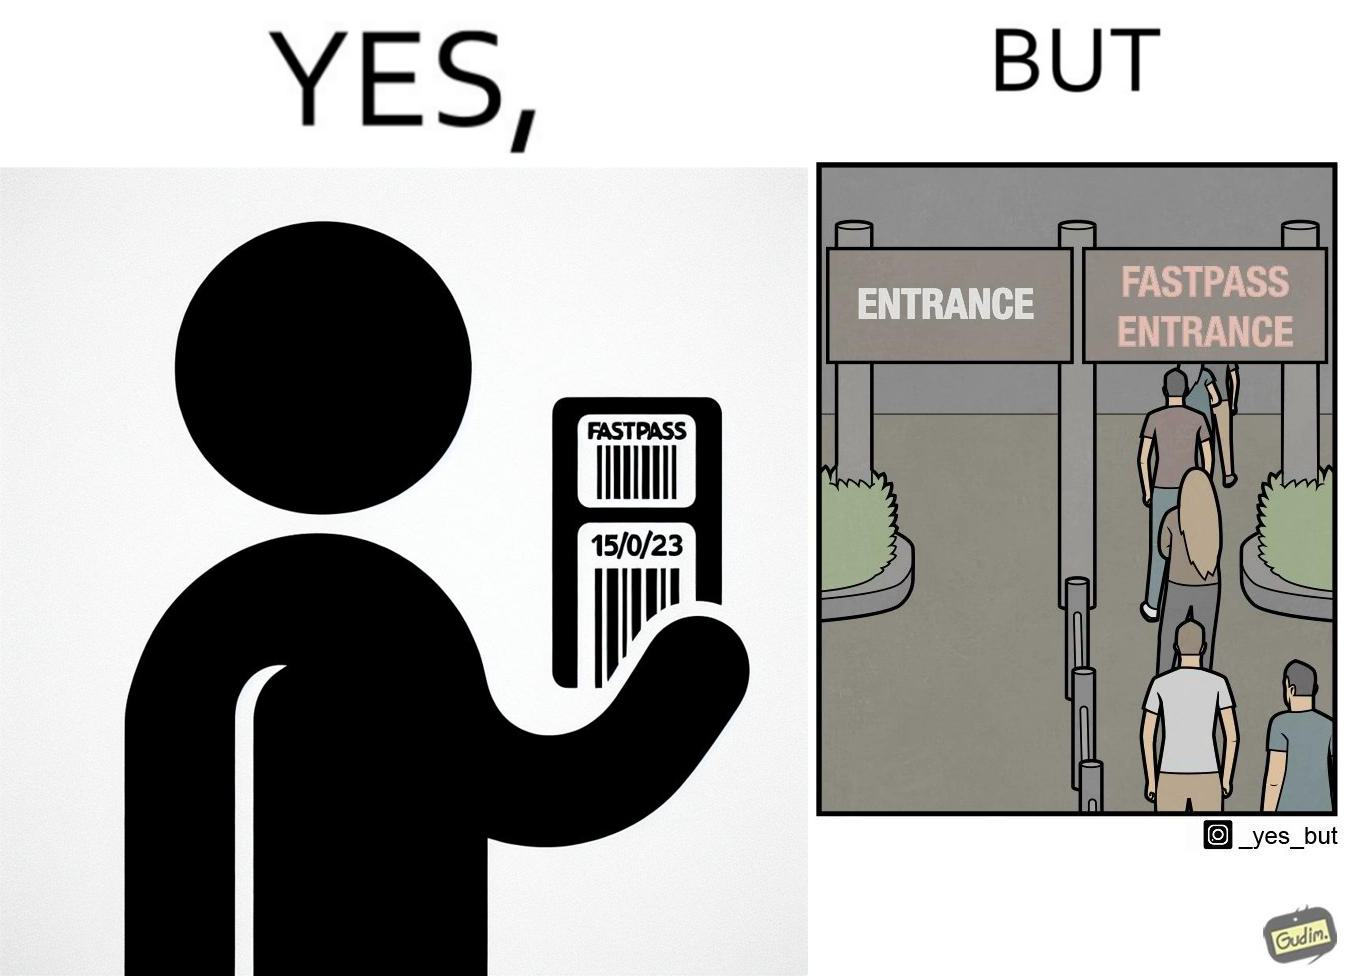Compare the left and right sides of this image. In the left part of the image: a person holding a "FASTPASS ENTRANCE" ticket or token of date "15/05/23" with some barcode In the right part of the image: people in a long queue in front of "FASTPASS ENTRANCE"  gate and "ENTRANCE" gate is vacant without any queue 